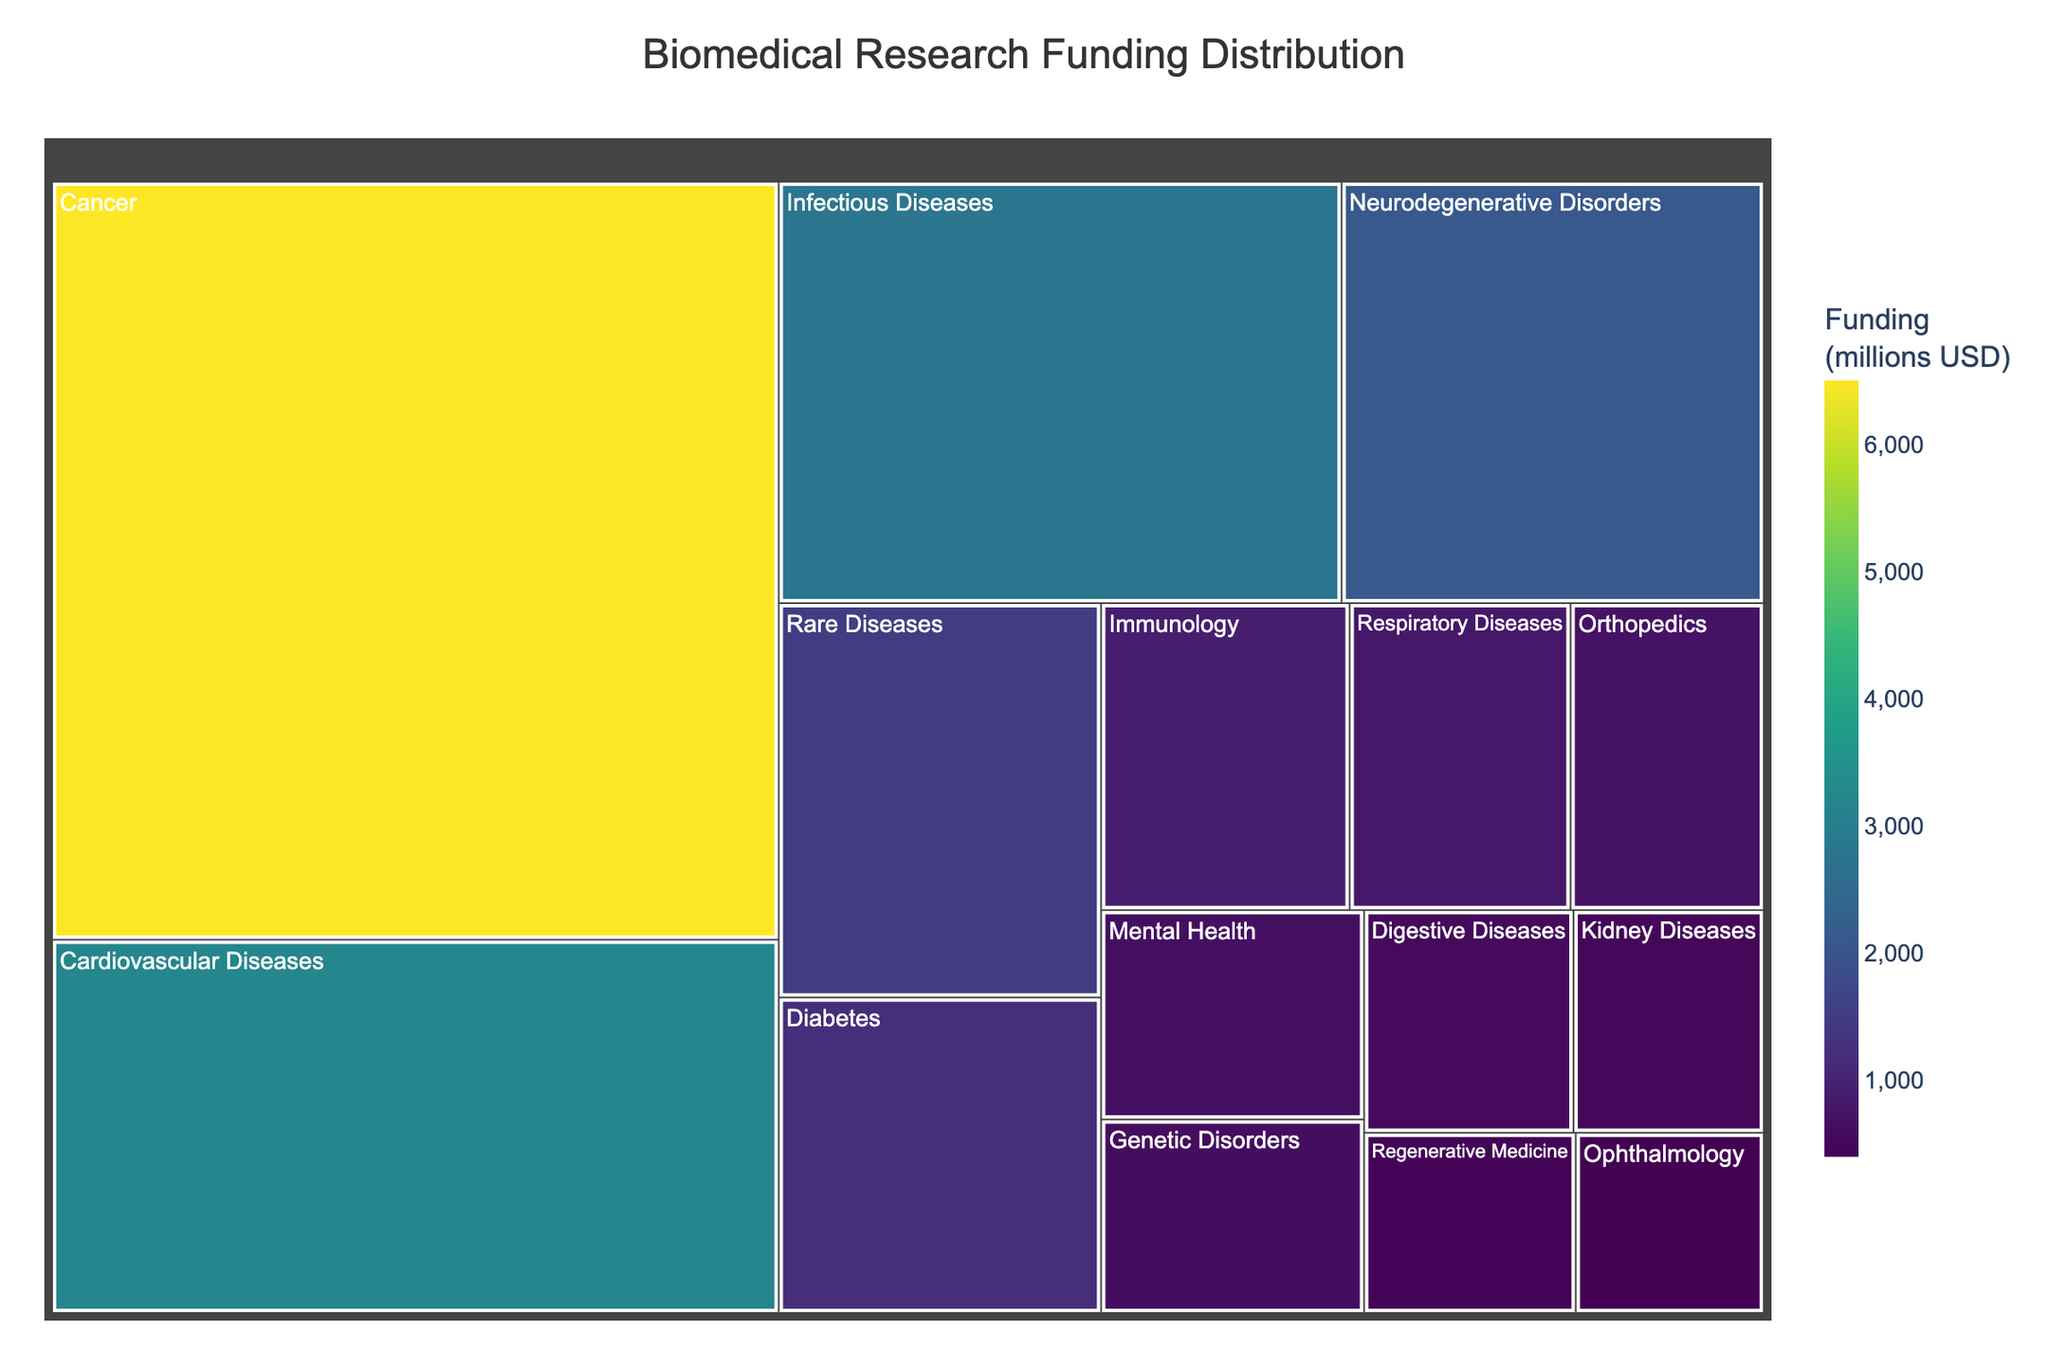What is the title of the treemap? The title of the treemap is displayed at the top of the figure. It reads 'Biomedical Research Funding Distribution'.
Answer: Biomedical Research Funding Distribution Which disease category received the highest funding? The box size in a treemap represents the funding amount, and the largest box is for Cancer.
Answer: Cancer Which disease category received the lowest funding? The smallest box in the treemap represents the funding amount, and the smallest box is for Ophthalmology.
Answer: Ophthalmology How does the funding for Cardiovascular Diseases compare to Cancer? The treemap shows that Cancer has the largest box, meaning it has the highest funding. Cardiovascular Diseases have a smaller box compared to Cancer, indicating lesser funding.
Answer: Cancer has more funding than Cardiovascular Diseases What is the total funding amount for Cancer, Cardiovascular Diseases, and Infectious Diseases combined? Sum the funding amounts: Cancer (6500) + Cardiovascular Diseases (3200) + Infectious Diseases (2800). So, the total is 6500 + 3200 + 2800 = 12500.
Answer: 12500 million USD What is the average funding amount across all disease categories? First, sum the funding amounts for all categories, then divide by the number of categories. Total funding is 26900, and there are 15 categories. Thus, the average is 26900 / 15.
Answer: 1793.33 million USD How much more funding does Cancer receive compared to Diabetes? Subtract the funding amount for Diabetes from the funding for Cancer: 6500 - 1200.
Answer: 5300 million USD What color is used to represent the highest funding in the treemap? The treemap uses a 'Viridis' color scale, which typically represents higher values with colors near the greenish-yellow side of the spectrum.
Answer: Greenish-yellow Among Mental Health, Genetic Disorders, and Digestive Diseases, which has the highest funding? By comparing the sizes of the respective boxes, Mental Health has the largest box among the three.
Answer: Mental Health What is the ratio of funding between Neurodegenerative Disorders and Rare Diseases? Divide the funding for Neurodegenerative Disorders by the funding for Rare Diseases: 2100 / 1500 = 1.40.
Answer: 1.40 